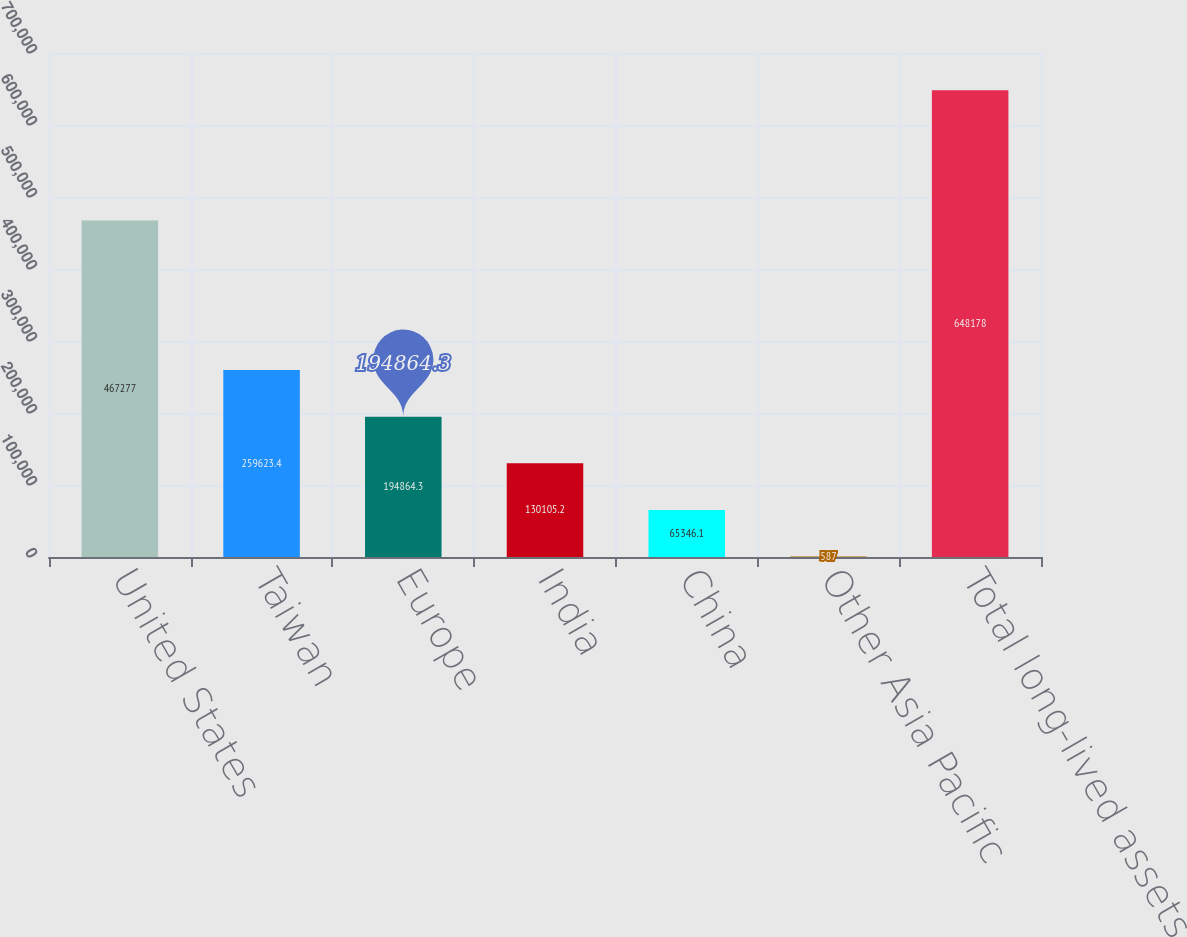Convert chart to OTSL. <chart><loc_0><loc_0><loc_500><loc_500><bar_chart><fcel>United States<fcel>Taiwan<fcel>Europe<fcel>India<fcel>China<fcel>Other Asia Pacific<fcel>Total long-lived assets<nl><fcel>467277<fcel>259623<fcel>194864<fcel>130105<fcel>65346.1<fcel>587<fcel>648178<nl></chart> 